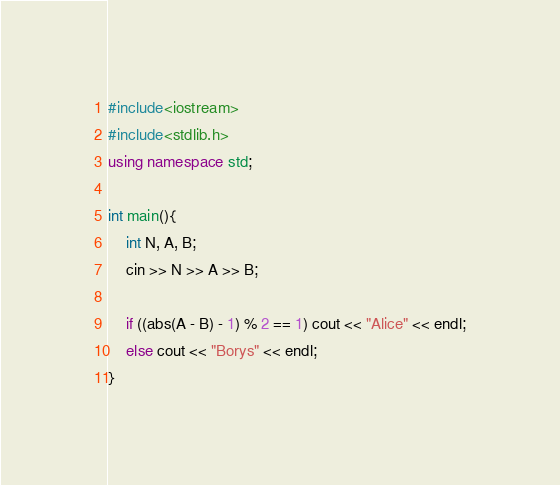<code> <loc_0><loc_0><loc_500><loc_500><_C++_>#include<iostream>
#include<stdlib.h>
using namespace std;

int main(){
    int N, A, B;
    cin >> N >> A >> B;

    if ((abs(A - B) - 1) % 2 == 1) cout << "Alice" << endl;
    else cout << "Borys" << endl;
}</code> 